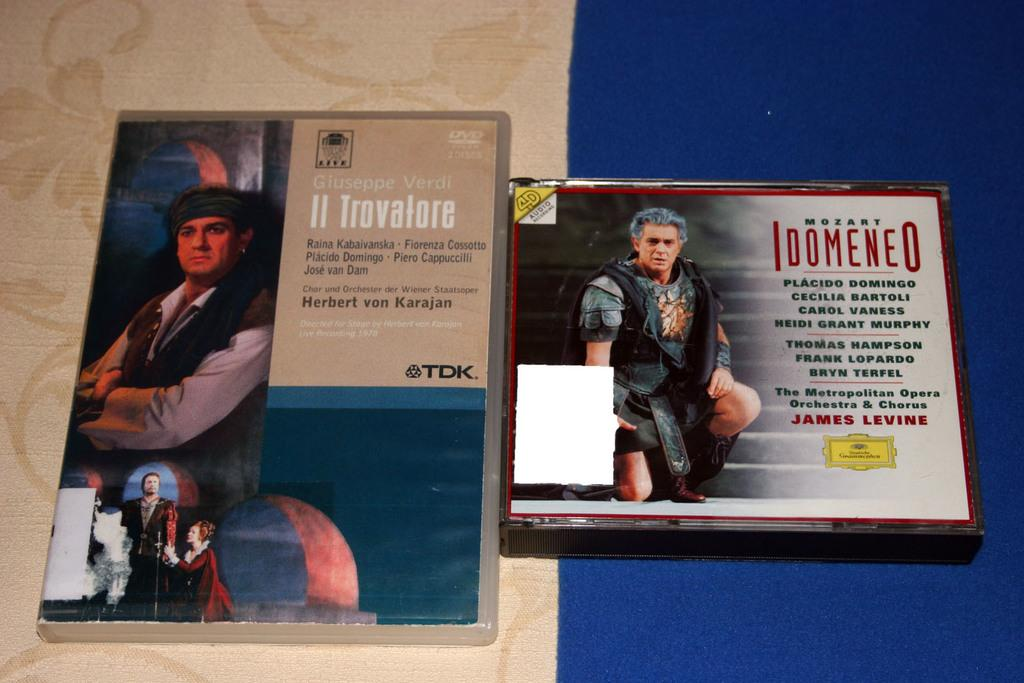<image>
Render a clear and concise summary of the photo. A DVD of a live performance of Il Trova next to a CD case of Mozart's Idomeneo. 